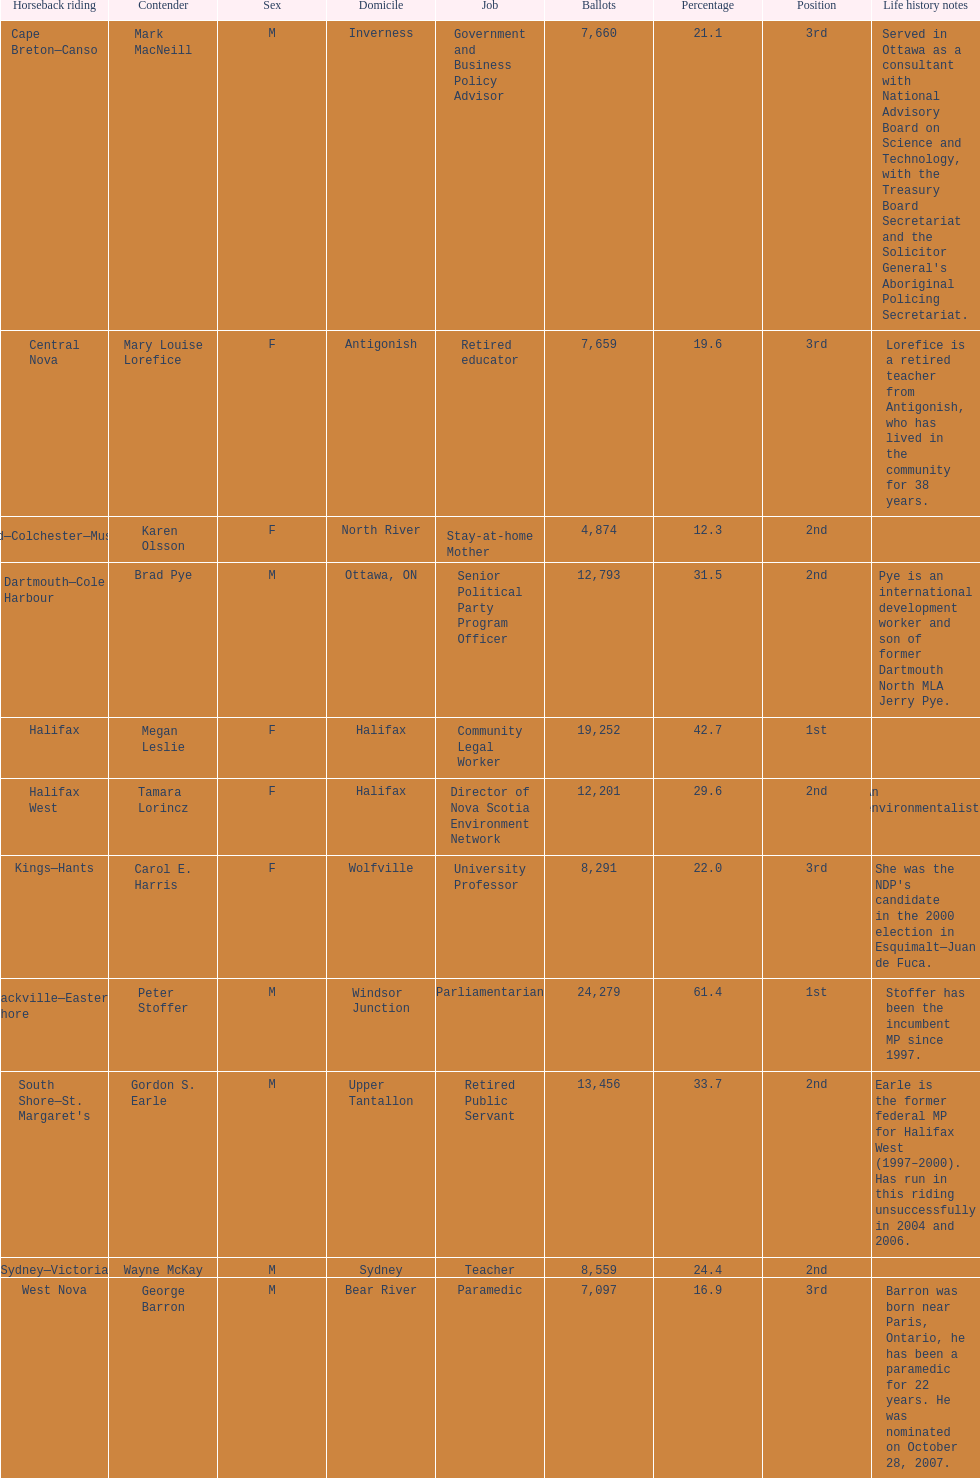How many of the candidates were females? 5. Help me parse the entirety of this table. {'header': ['Horseback riding', 'Contender', 'Sex', 'Domicile', 'Job', 'Ballots', 'Percentage', 'Position', 'Life history notes'], 'rows': [['Cape Breton—Canso', 'Mark MacNeill', 'M', 'Inverness', 'Government and Business Policy Advisor', '7,660', '21.1', '3rd', "Served in Ottawa as a consultant with National Advisory Board on Science and Technology, with the Treasury Board Secretariat and the Solicitor General's Aboriginal Policing Secretariat."], ['Central Nova', 'Mary Louise Lorefice', 'F', 'Antigonish', 'Retired educator', '7,659', '19.6', '3rd', 'Lorefice is a retired teacher from Antigonish, who has lived in the community for 38 years.'], ['Cumberland—Colchester—Musquodoboit Valley', 'Karen Olsson', 'F', 'North River', 'Stay-at-home Mother', '4,874', '12.3', '2nd', ''], ['Dartmouth—Cole Harbour', 'Brad Pye', 'M', 'Ottawa, ON', 'Senior Political Party Program Officer', '12,793', '31.5', '2nd', 'Pye is an international development worker and son of former Dartmouth North MLA Jerry Pye.'], ['Halifax', 'Megan Leslie', 'F', 'Halifax', 'Community Legal Worker', '19,252', '42.7', '1st', ''], ['Halifax West', 'Tamara Lorincz', 'F', 'Halifax', 'Director of Nova Scotia Environment Network', '12,201', '29.6', '2nd', 'An environmentalist.'], ['Kings—Hants', 'Carol E. Harris', 'F', 'Wolfville', 'University Professor', '8,291', '22.0', '3rd', "She was the NDP's candidate in the 2000 election in Esquimalt—Juan de Fuca."], ['Sackville—Eastern Shore', 'Peter Stoffer', 'M', 'Windsor Junction', 'Parliamentarian', '24,279', '61.4', '1st', 'Stoffer has been the incumbent MP since 1997.'], ["South Shore—St. Margaret's", 'Gordon S. Earle', 'M', 'Upper Tantallon', 'Retired Public Servant', '13,456', '33.7', '2nd', 'Earle is the former federal MP for Halifax West (1997–2000). Has run in this riding unsuccessfully in 2004 and 2006.'], ['Sydney—Victoria', 'Wayne McKay', 'M', 'Sydney', 'Teacher', '8,559', '24.4', '2nd', ''], ['West Nova', 'George Barron', 'M', 'Bear River', 'Paramedic', '7,097', '16.9', '3rd', 'Barron was born near Paris, Ontario, he has been a paramedic for 22 years. He was nominated on October 28, 2007.']]} 